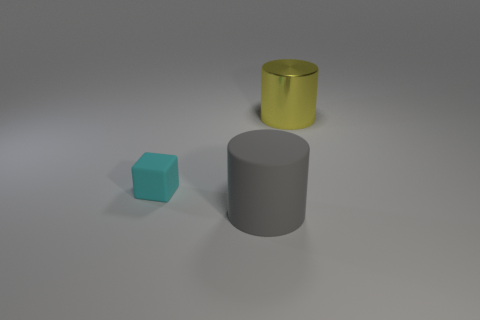Are there any other things that are the same size as the cyan matte block?
Your answer should be compact. No. The large cylinder that is made of the same material as the small cyan object is what color?
Your answer should be very brief. Gray. Is the material of the tiny cube the same as the big object behind the small cube?
Give a very brief answer. No. The object that is in front of the yellow cylinder and right of the tiny cyan rubber block is what color?
Provide a short and direct response. Gray. What number of cubes are either big gray rubber objects or purple metallic things?
Your answer should be compact. 0. Do the cyan object and the thing to the right of the big gray cylinder have the same shape?
Give a very brief answer. No. There is a thing that is both behind the large gray matte object and right of the matte block; what is its size?
Your answer should be very brief. Large. What shape is the cyan object?
Give a very brief answer. Cube. There is a rubber object left of the big gray thing; is there a large gray matte cylinder on the left side of it?
Offer a terse response. No. There is a cylinder that is in front of the large yellow shiny cylinder; what number of big gray matte objects are behind it?
Offer a terse response. 0. 